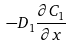<formula> <loc_0><loc_0><loc_500><loc_500>- D _ { 1 } \frac { \partial C _ { 1 } } { \partial x }</formula> 